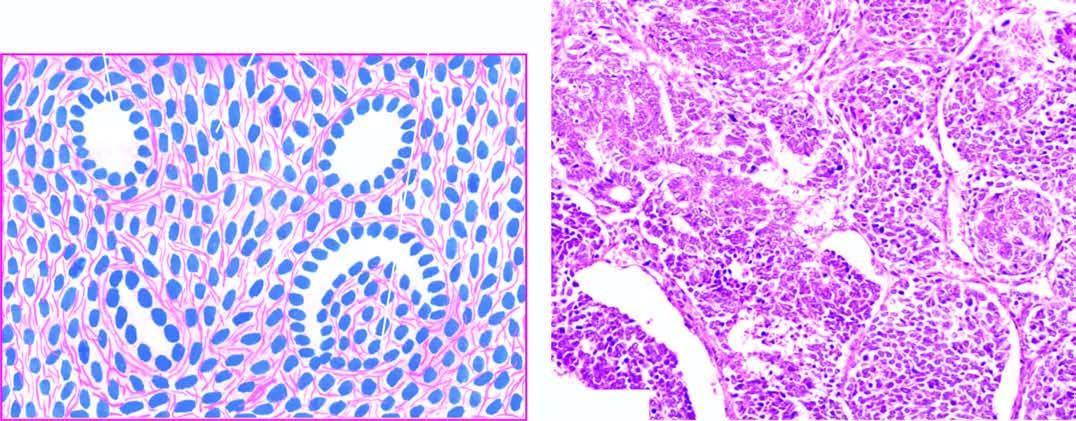re a few abortive tubules and poorlyformed glomerular structures present in it?
Answer the question using a single word or phrase. Yes 